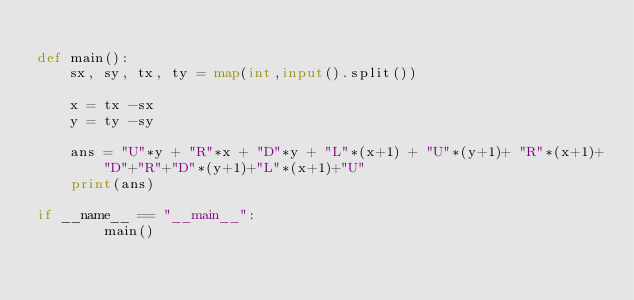<code> <loc_0><loc_0><loc_500><loc_500><_Python_>
def main():
    sx, sy, tx, ty = map(int,input().split())

    x = tx -sx
    y = ty -sy

    ans = "U"*y + "R"*x + "D"*y + "L"*(x+1) + "U"*(y+1)+ "R"*(x+1)+"D"+"R"+"D"*(y+1)+"L"*(x+1)+"U"
    print(ans)

if __name__ == "__main__":
        main()
</code> 